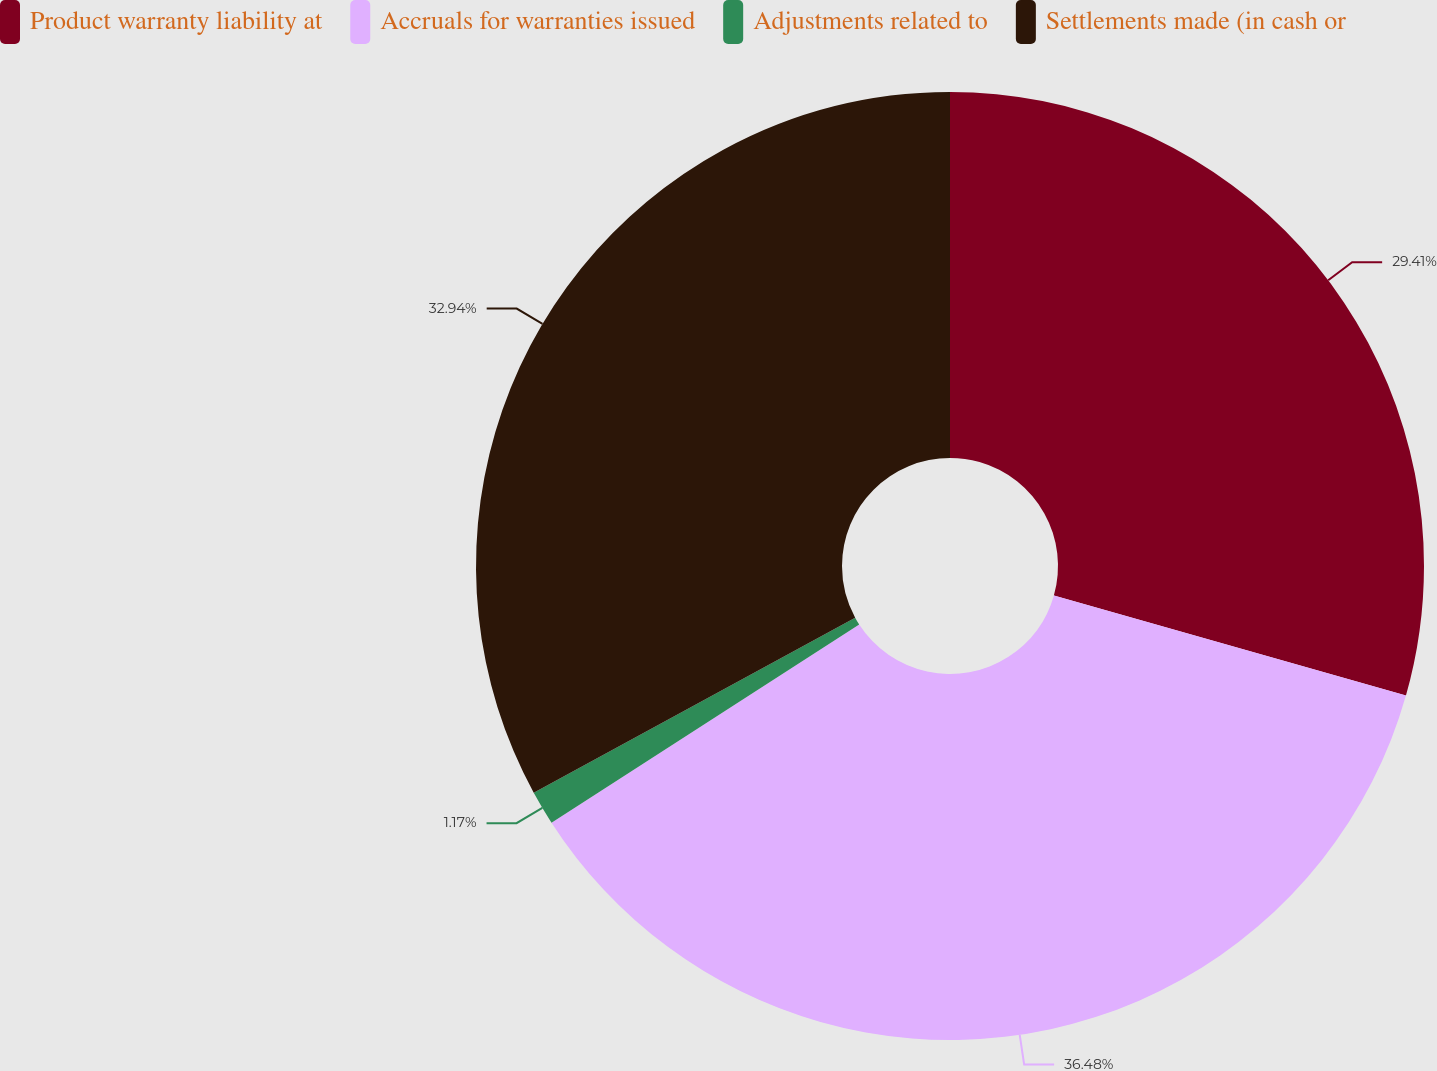Convert chart to OTSL. <chart><loc_0><loc_0><loc_500><loc_500><pie_chart><fcel>Product warranty liability at<fcel>Accruals for warranties issued<fcel>Adjustments related to<fcel>Settlements made (in cash or<nl><fcel>29.41%<fcel>36.49%<fcel>1.17%<fcel>32.94%<nl></chart> 